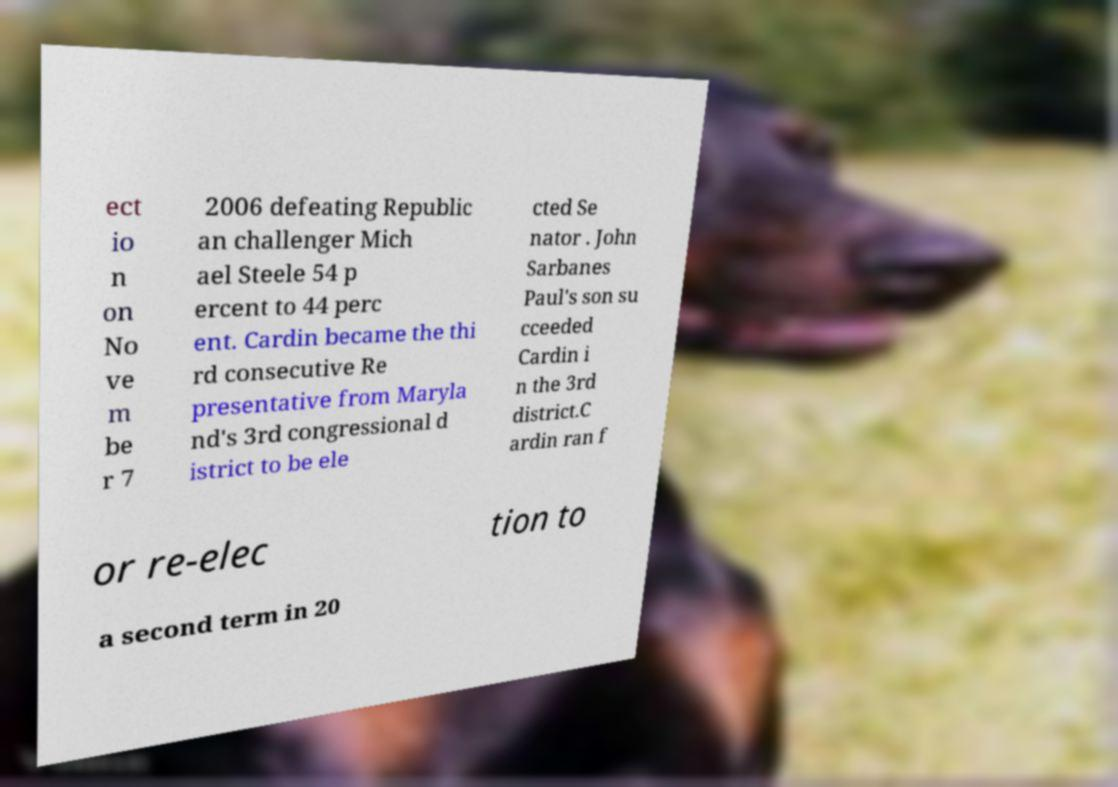Can you read and provide the text displayed in the image?This photo seems to have some interesting text. Can you extract and type it out for me? ect io n on No ve m be r 7 2006 defeating Republic an challenger Mich ael Steele 54 p ercent to 44 perc ent. Cardin became the thi rd consecutive Re presentative from Maryla nd's 3rd congressional d istrict to be ele cted Se nator . John Sarbanes Paul's son su cceeded Cardin i n the 3rd district.C ardin ran f or re-elec tion to a second term in 20 